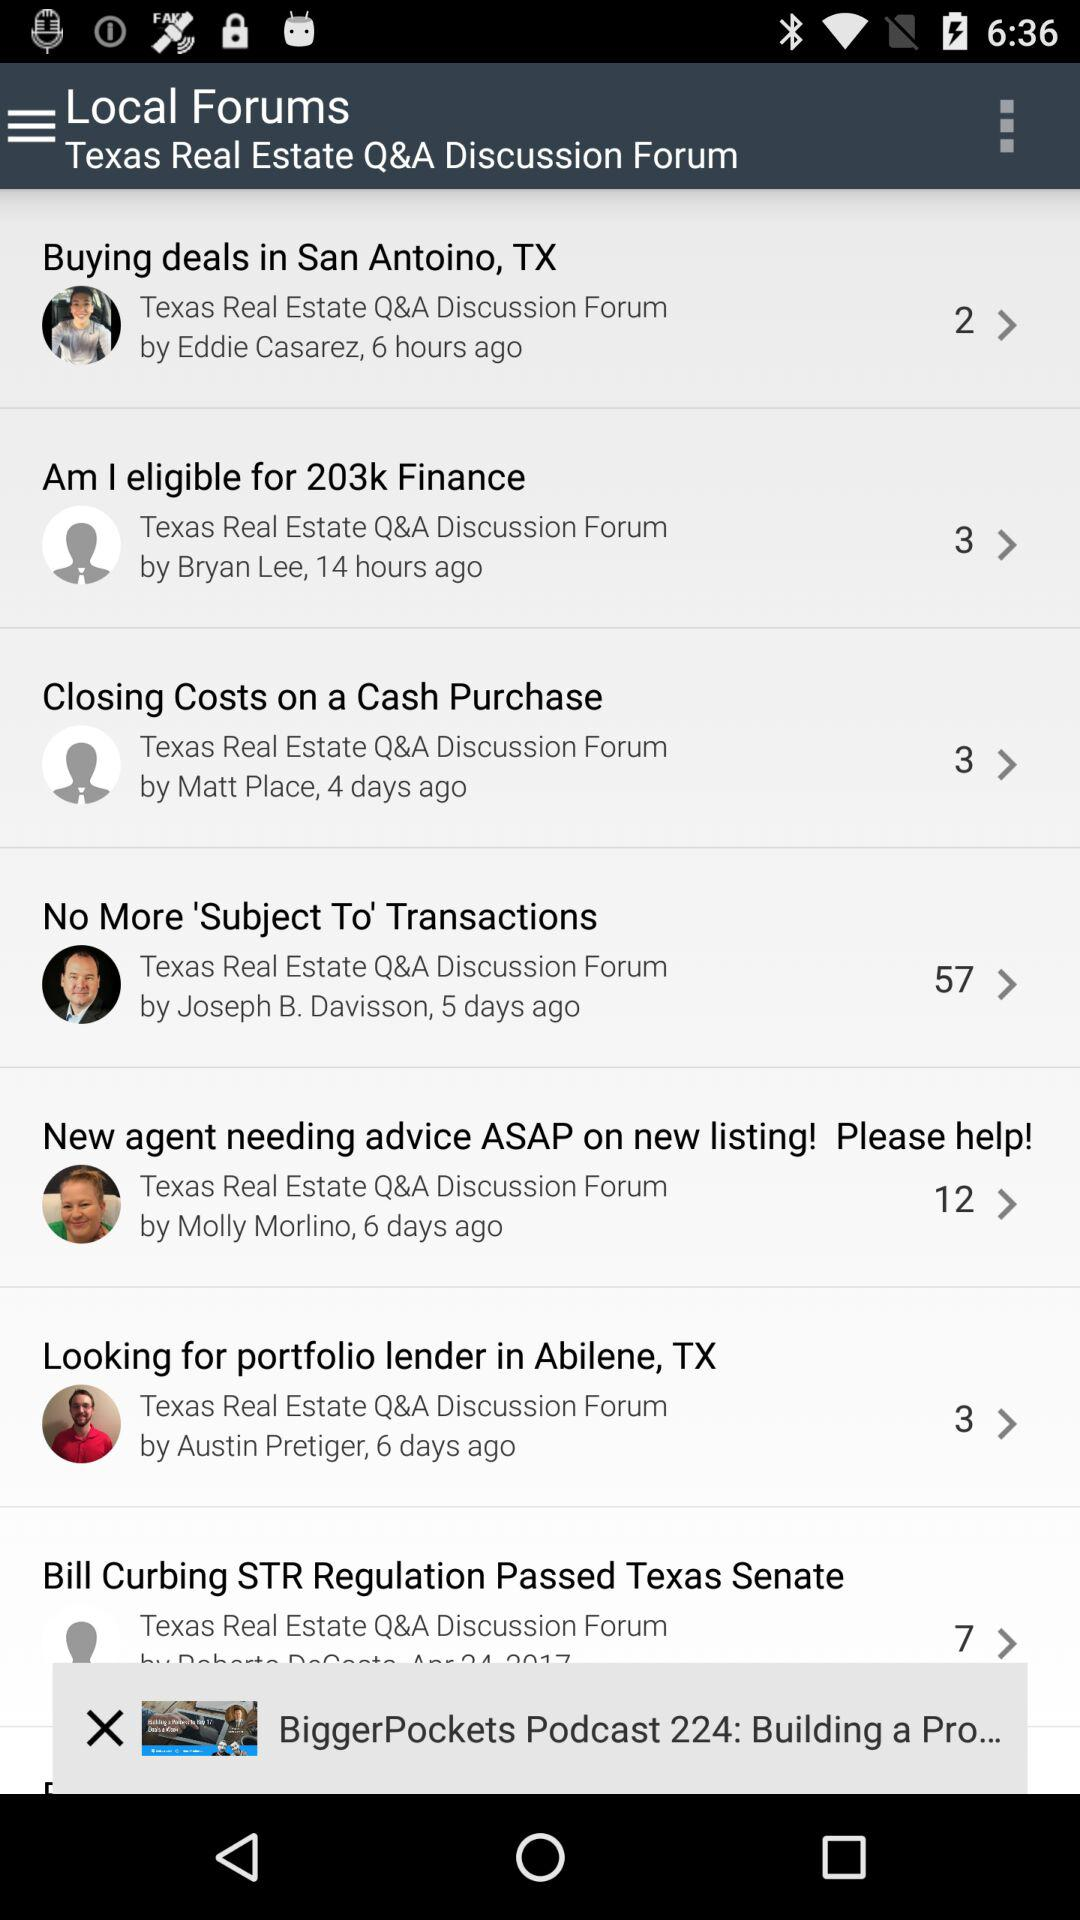Which discussions in forums have been posted six hours ago? The discussion is "Buying deals in San Antoino, TX". 